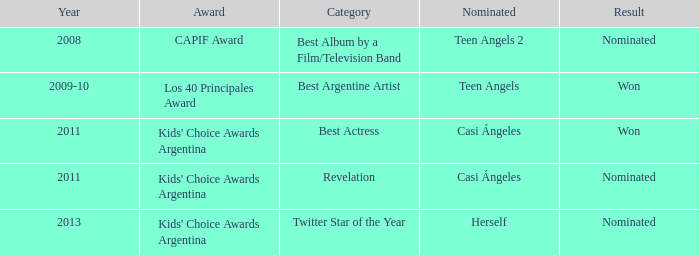Name the performance nominated for a Capif Award. Teen Angels 2. 